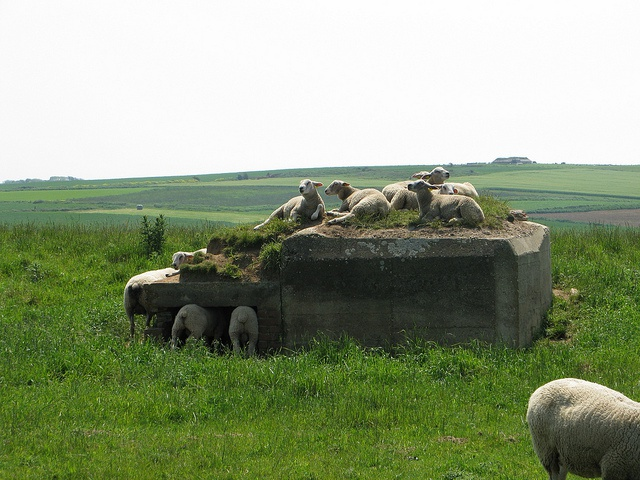Describe the objects in this image and their specific colors. I can see sheep in white, black, gray, darkgreen, and ivory tones, sheep in white, black, gray, darkgreen, and darkgray tones, sheep in white, black, gray, and darkgreen tones, sheep in white, gray, black, darkgreen, and darkgray tones, and sheep in white, black, ivory, darkgreen, and beige tones in this image. 